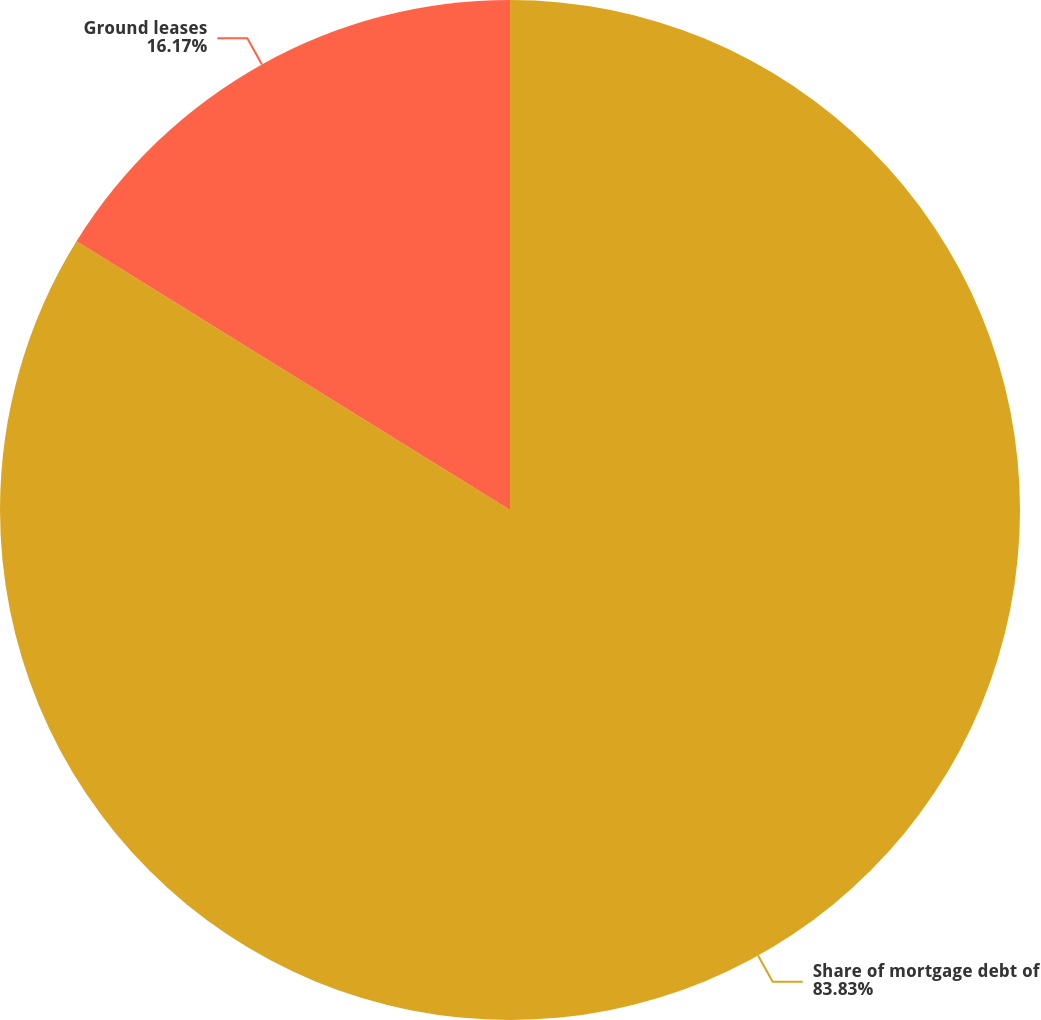Convert chart to OTSL. <chart><loc_0><loc_0><loc_500><loc_500><pie_chart><fcel>Share of mortgage debt of<fcel>Ground leases<nl><fcel>83.83%<fcel>16.17%<nl></chart> 